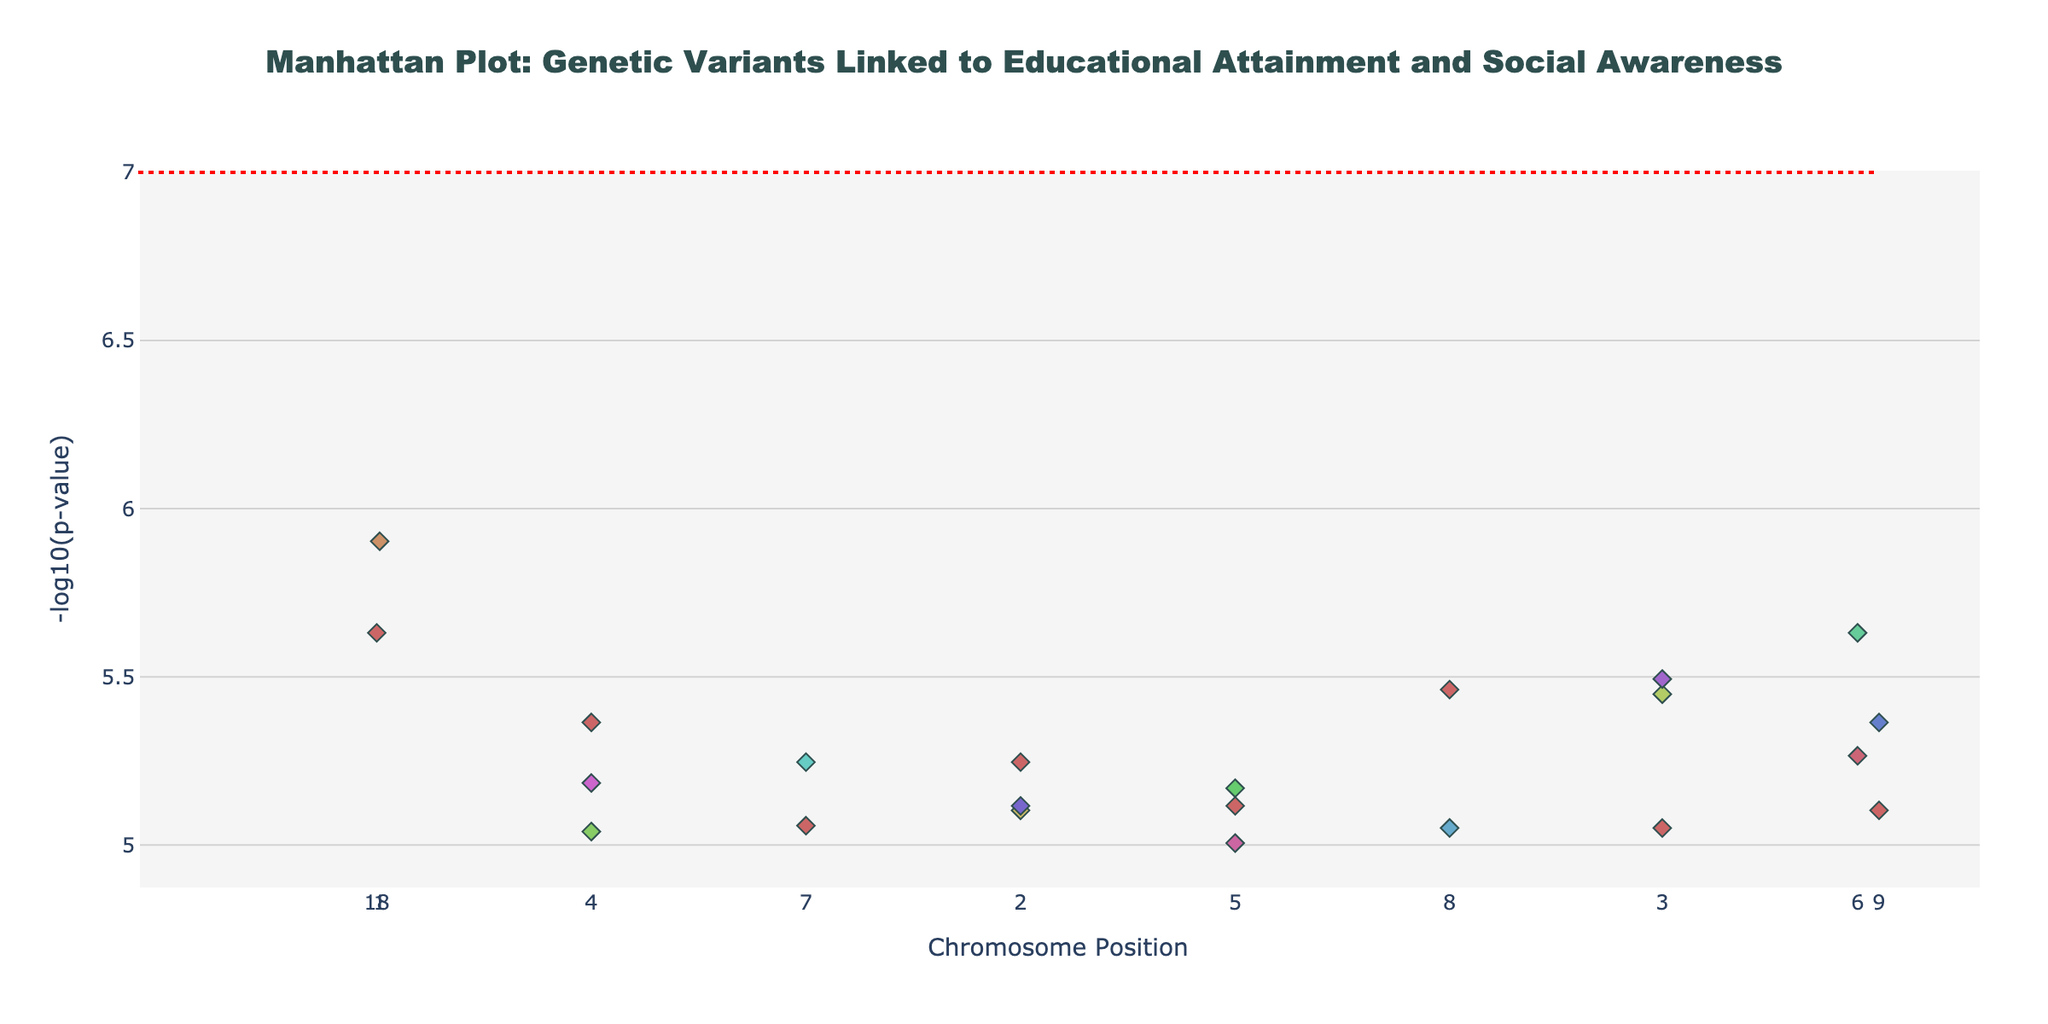what is the title of the plot? The title is typically located at the top of the plot and is usually the most prominent text. In this plot, look for the large, centered text with a distinctive font.
Answer: Manhattan Plot: Genetic Variants Linked to Educational Attainment and Social Awareness Which chromosome has the genetic variant with the lowest p-value? To determine the chromosome with the lowest p-value, look for the highest point on the y-axis (-log10(p-value)) since the y-axis is based on the negative log of the p-value. Check the chromosome label for that point.
Answer: Chromosome 1 How many genetic variants have a logp-value greater than 6? Count the number of points that are above the value of 6 on the y-axis, which represents -log10(p-value). These points are visually higher than the horizontal line at y=6.
Answer: 22 Which gene is associated with the SNP having position 12500000 on chromosome 1? Locate the specified position on the x-axis for chromosome 1 and find the corresponding point. The gene name is shown in the hover information for that point.
Answer: NRXN1 What color marker is used for chromosome 5? Each chromosome is represented with a unique color. Identify the marker color associated with chromosome 5, usually by looking at the plot's color differentiation.
Answer: Light brown Which chromosomes have more than two genetic variants each? Count the number of points for each chromosome and identify those with more than two. Check the hover information to see which chromosomes these points correspond to.
Answer: Chromosomes 1, 5, 8, 10, 13, 14, 15, 17, 20, and 21 What is the significance threshold level indicated by the horizontal line, and what does it represent? The horizontal line is typically drawn to indicate a specific threshold value of -log10(p-value). Identify the y-value of this line and interpret its significance.
Answer: 7; It represents the significance threshold for GWAS Which genetic variant linked to educational attainment and social awareness is located at position 23456789 on chromosome 4? Locate the specified chromosome and position on the plot, then hover or refer to the annotation for the SNP at that position.
Answer: rs2345678 How does the -log10(p-value) of the variant at position 45678901 on chromosome 2 compare to the variant at the same position on chromosome 19? Compare the heights of the points (representing -log10(p-value)) at the specified positions for both chromosomes. The higher point represents a lower p-value.
Answer: The variant on chromosome 19 has a higher -log10(p-value) than the variant on chromosome 2 Which SNP has the highest -log10(p-value) on chromosome 6, and what gene is it associated with? Identify the highest point on chromosome 6 by examining the y-values and then refer to the hover information for that specific point.
Answer: rs4567890; FOXP1 